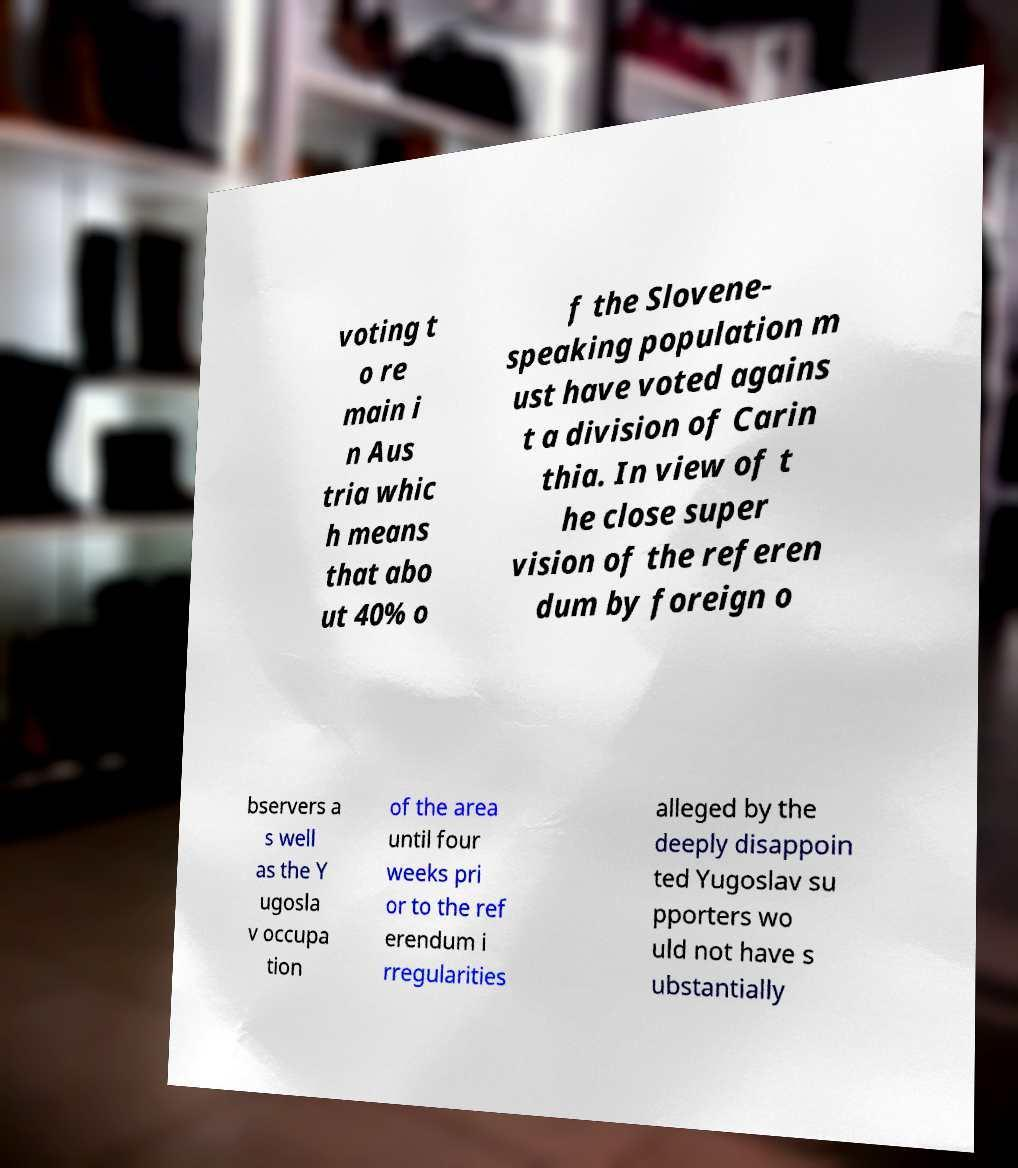Can you accurately transcribe the text from the provided image for me? voting t o re main i n Aus tria whic h means that abo ut 40% o f the Slovene- speaking population m ust have voted agains t a division of Carin thia. In view of t he close super vision of the referen dum by foreign o bservers a s well as the Y ugosla v occupa tion of the area until four weeks pri or to the ref erendum i rregularities alleged by the deeply disappoin ted Yugoslav su pporters wo uld not have s ubstantially 